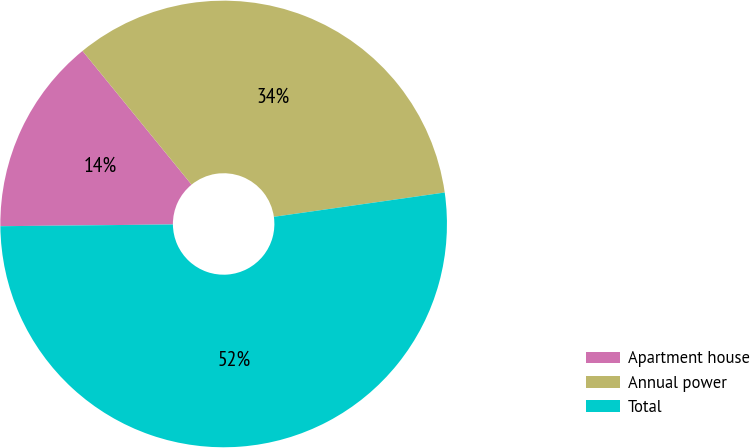Convert chart. <chart><loc_0><loc_0><loc_500><loc_500><pie_chart><fcel>Apartment house<fcel>Annual power<fcel>Total<nl><fcel>14.27%<fcel>33.64%<fcel>52.09%<nl></chart> 